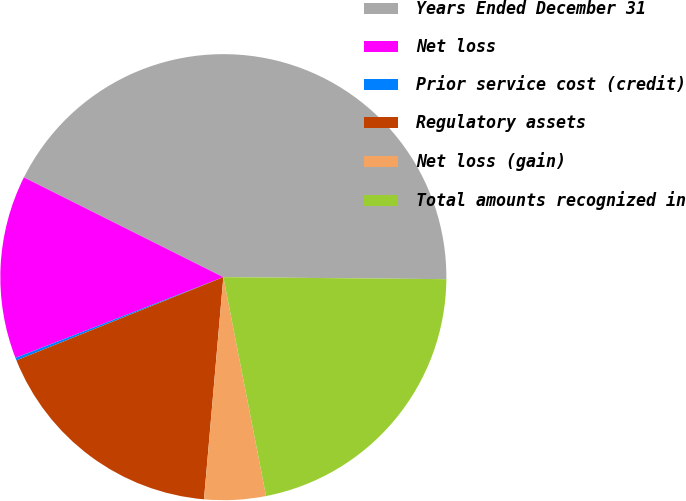<chart> <loc_0><loc_0><loc_500><loc_500><pie_chart><fcel>Years Ended December 31<fcel>Net loss<fcel>Prior service cost (credit)<fcel>Regulatory assets<fcel>Net loss (gain)<fcel>Total amounts recognized in<nl><fcel>42.76%<fcel>13.28%<fcel>0.19%<fcel>17.53%<fcel>4.45%<fcel>21.79%<nl></chart> 